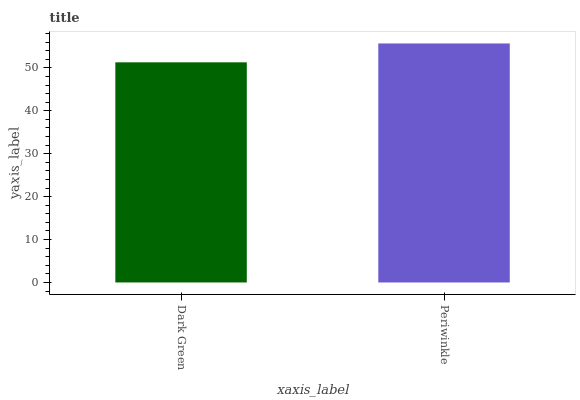Is Periwinkle the minimum?
Answer yes or no. No. Is Periwinkle greater than Dark Green?
Answer yes or no. Yes. Is Dark Green less than Periwinkle?
Answer yes or no. Yes. Is Dark Green greater than Periwinkle?
Answer yes or no. No. Is Periwinkle less than Dark Green?
Answer yes or no. No. Is Periwinkle the high median?
Answer yes or no. Yes. Is Dark Green the low median?
Answer yes or no. Yes. Is Dark Green the high median?
Answer yes or no. No. Is Periwinkle the low median?
Answer yes or no. No. 